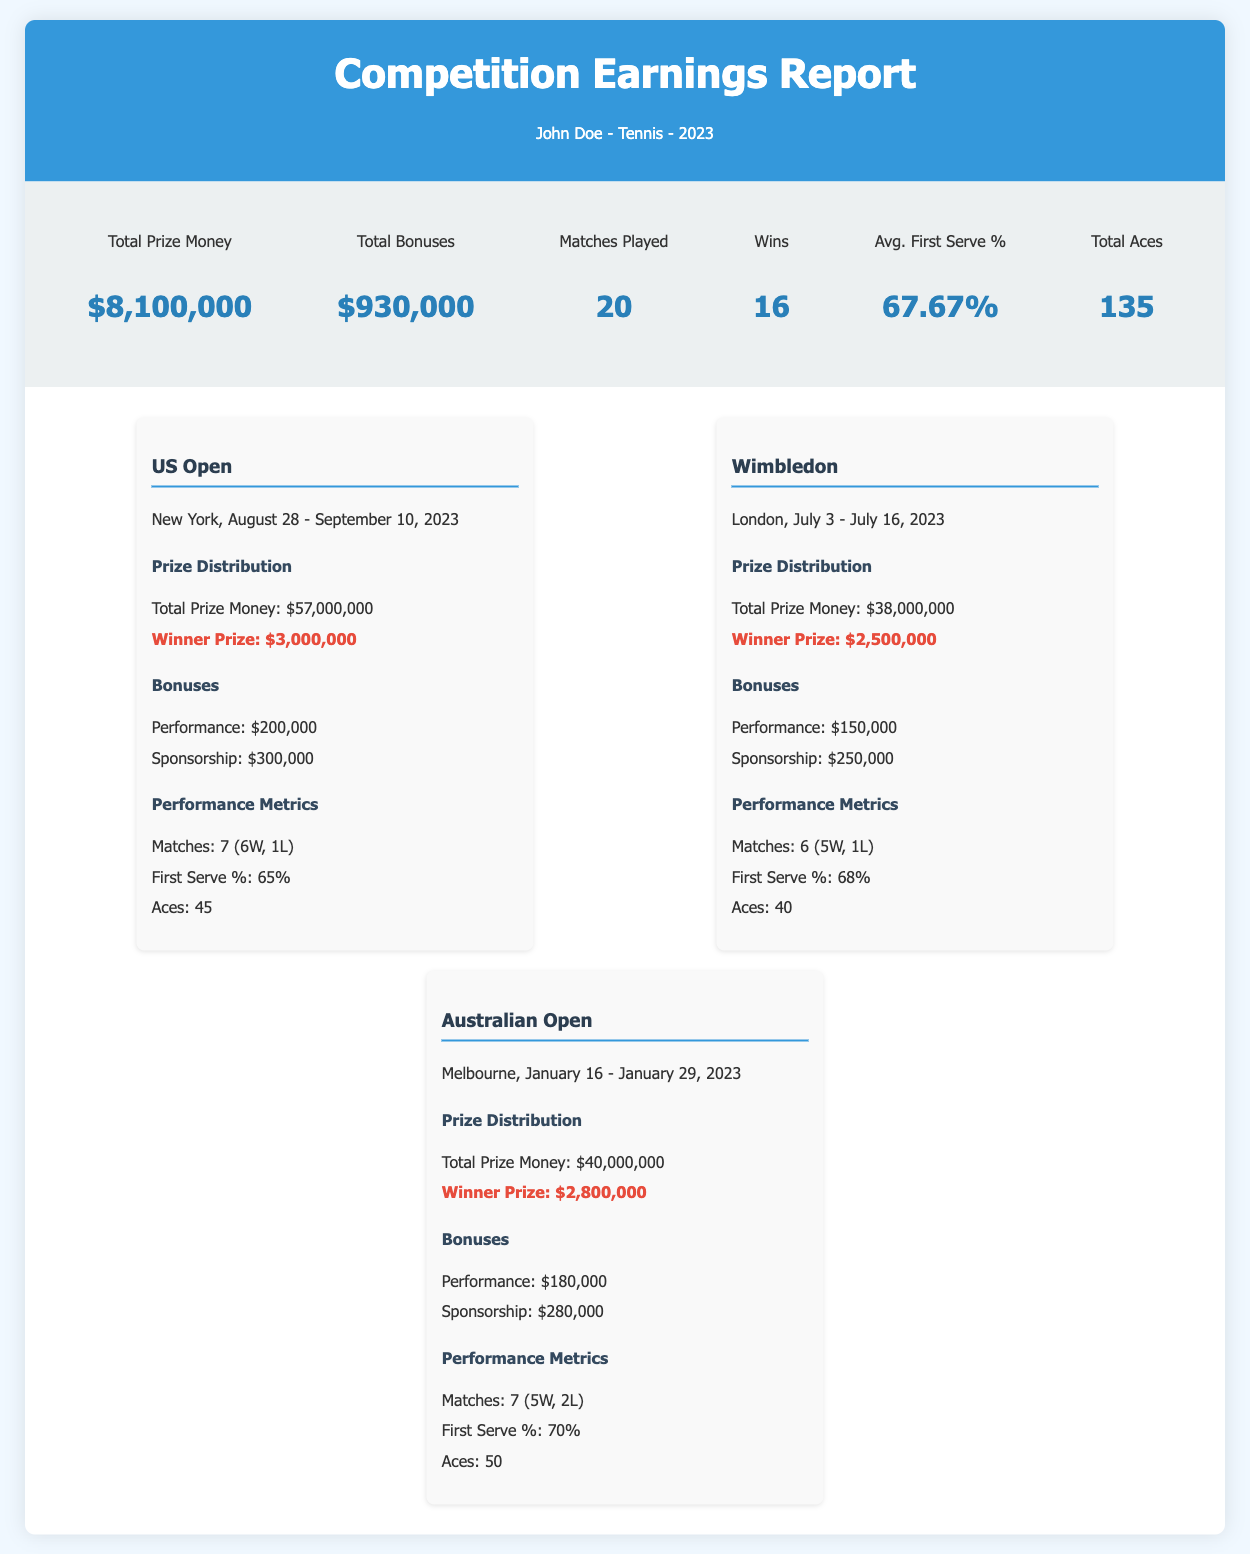What is the total prize money earned in 2023? The total prize money is explicitly listed in the summary section of the report as $8,100,000.
Answer: $8,100,000 What was the winner's prize for the US Open? The report specifies the winner's prize within the US Open tournament section as $3,000,000.
Answer: $3,000,000 How many matches did John Doe win in Wimbledon? The report provides the match results for Wimbledon, indicating 5 wins out of 6 matches played.
Answer: 5 What is the total amount received in bonuses? The total bonuses are summarized in the report as $930,000.
Answer: $930,000 What was John Doe's average first serve percentage? The average first serve percentage is detailed in the summary section of the report as 67.67%.
Answer: 67.67% How many total aces did John Doe achieve in the Australian Open? The performance metrics for the Australian Open indicate 50 total aces achieved in that tournament.
Answer: 50 Which tournament awarded the highest winner's prize? The document highlights the US Open as the tournament with the highest winner's prize of $3,000,000.
Answer: US Open How many tournaments are listed in the report? The report contains detailed information about three tournaments participated in during 2023.
Answer: 3 What was the performance bonus received from Wimbledon? The bonuses section of the Wimbledon tournament specifies a performance bonus of $150,000.
Answer: $150,000 